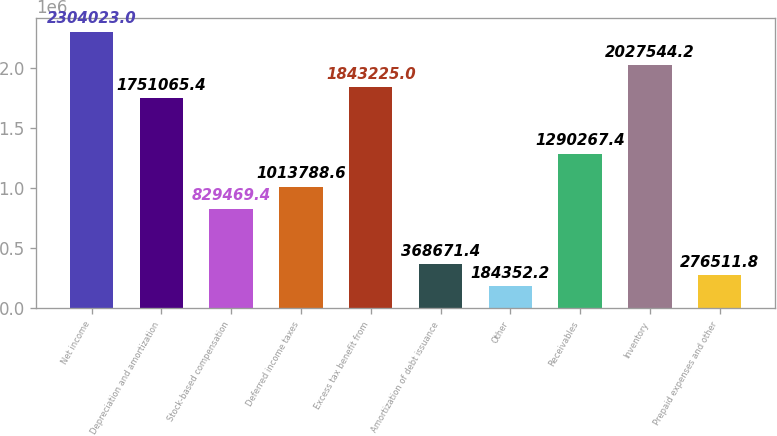Convert chart. <chart><loc_0><loc_0><loc_500><loc_500><bar_chart><fcel>Net income<fcel>Depreciation and amortization<fcel>Stock-based compensation<fcel>Deferred income taxes<fcel>Excess tax benefit from<fcel>Amortization of debt issuance<fcel>Other<fcel>Receivables<fcel>Inventory<fcel>Prepaid expenses and other<nl><fcel>2.30402e+06<fcel>1.75107e+06<fcel>829469<fcel>1.01379e+06<fcel>1.84322e+06<fcel>368671<fcel>184352<fcel>1.29027e+06<fcel>2.02754e+06<fcel>276512<nl></chart> 